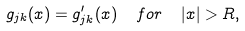<formula> <loc_0><loc_0><loc_500><loc_500>g _ { j k } ( x ) = g _ { j k } ^ { \prime } ( x ) \ \ f o r \ \ | x | > R ,</formula> 